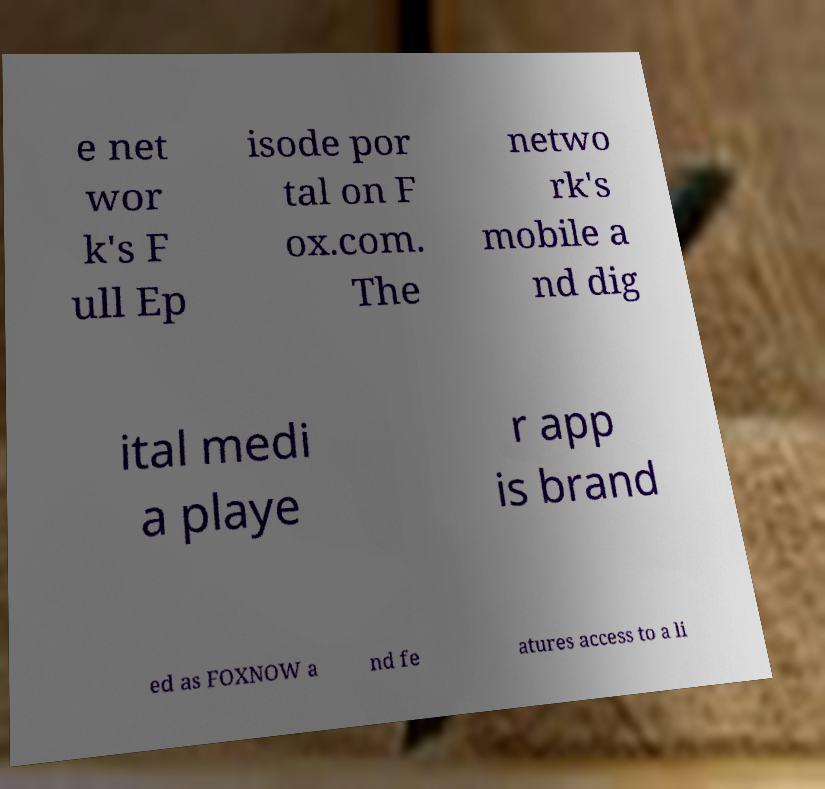What messages or text are displayed in this image? I need them in a readable, typed format. e net wor k's F ull Ep isode por tal on F ox.com. The netwo rk's mobile a nd dig ital medi a playe r app is brand ed as FOXNOW a nd fe atures access to a li 